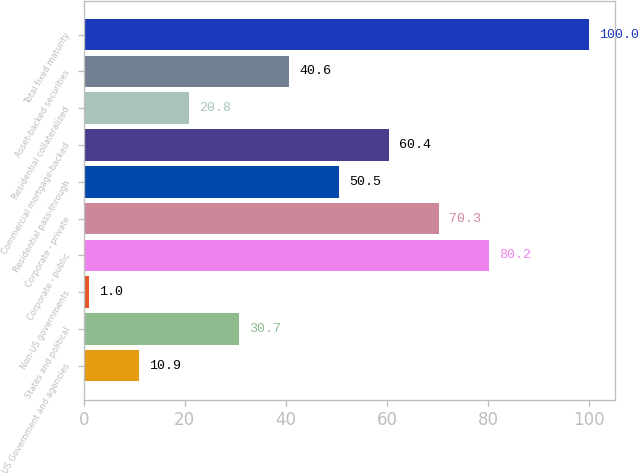<chart> <loc_0><loc_0><loc_500><loc_500><bar_chart><fcel>US Government and agencies<fcel>States and political<fcel>Non-US governments<fcel>Corporate - public<fcel>Corporate - private<fcel>Residential pass-through<fcel>Commercial mortgage-backed<fcel>Residential collateralized<fcel>Asset-backed securities<fcel>Total fixed maturity<nl><fcel>10.9<fcel>30.7<fcel>1<fcel>80.2<fcel>70.3<fcel>50.5<fcel>60.4<fcel>20.8<fcel>40.6<fcel>100<nl></chart> 